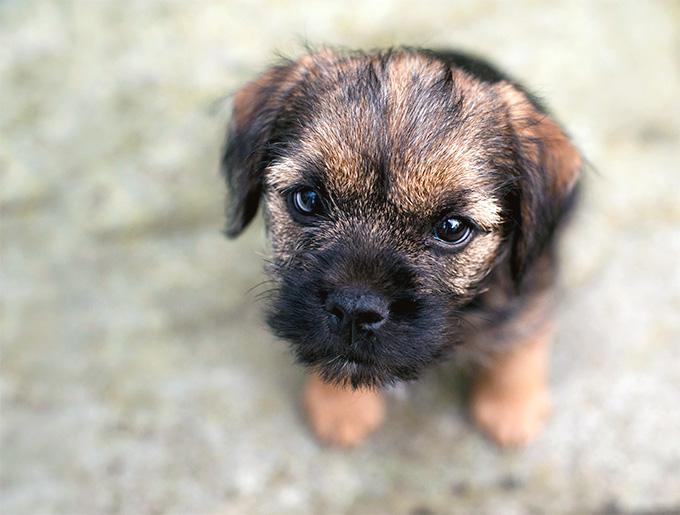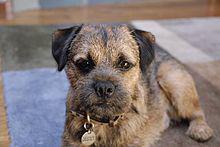The first image is the image on the left, the second image is the image on the right. Examine the images to the left and right. Is the description "The dog on the left image is facing left while the dog on the right image is facing directly towards the camera." accurate? Answer yes or no. No. 